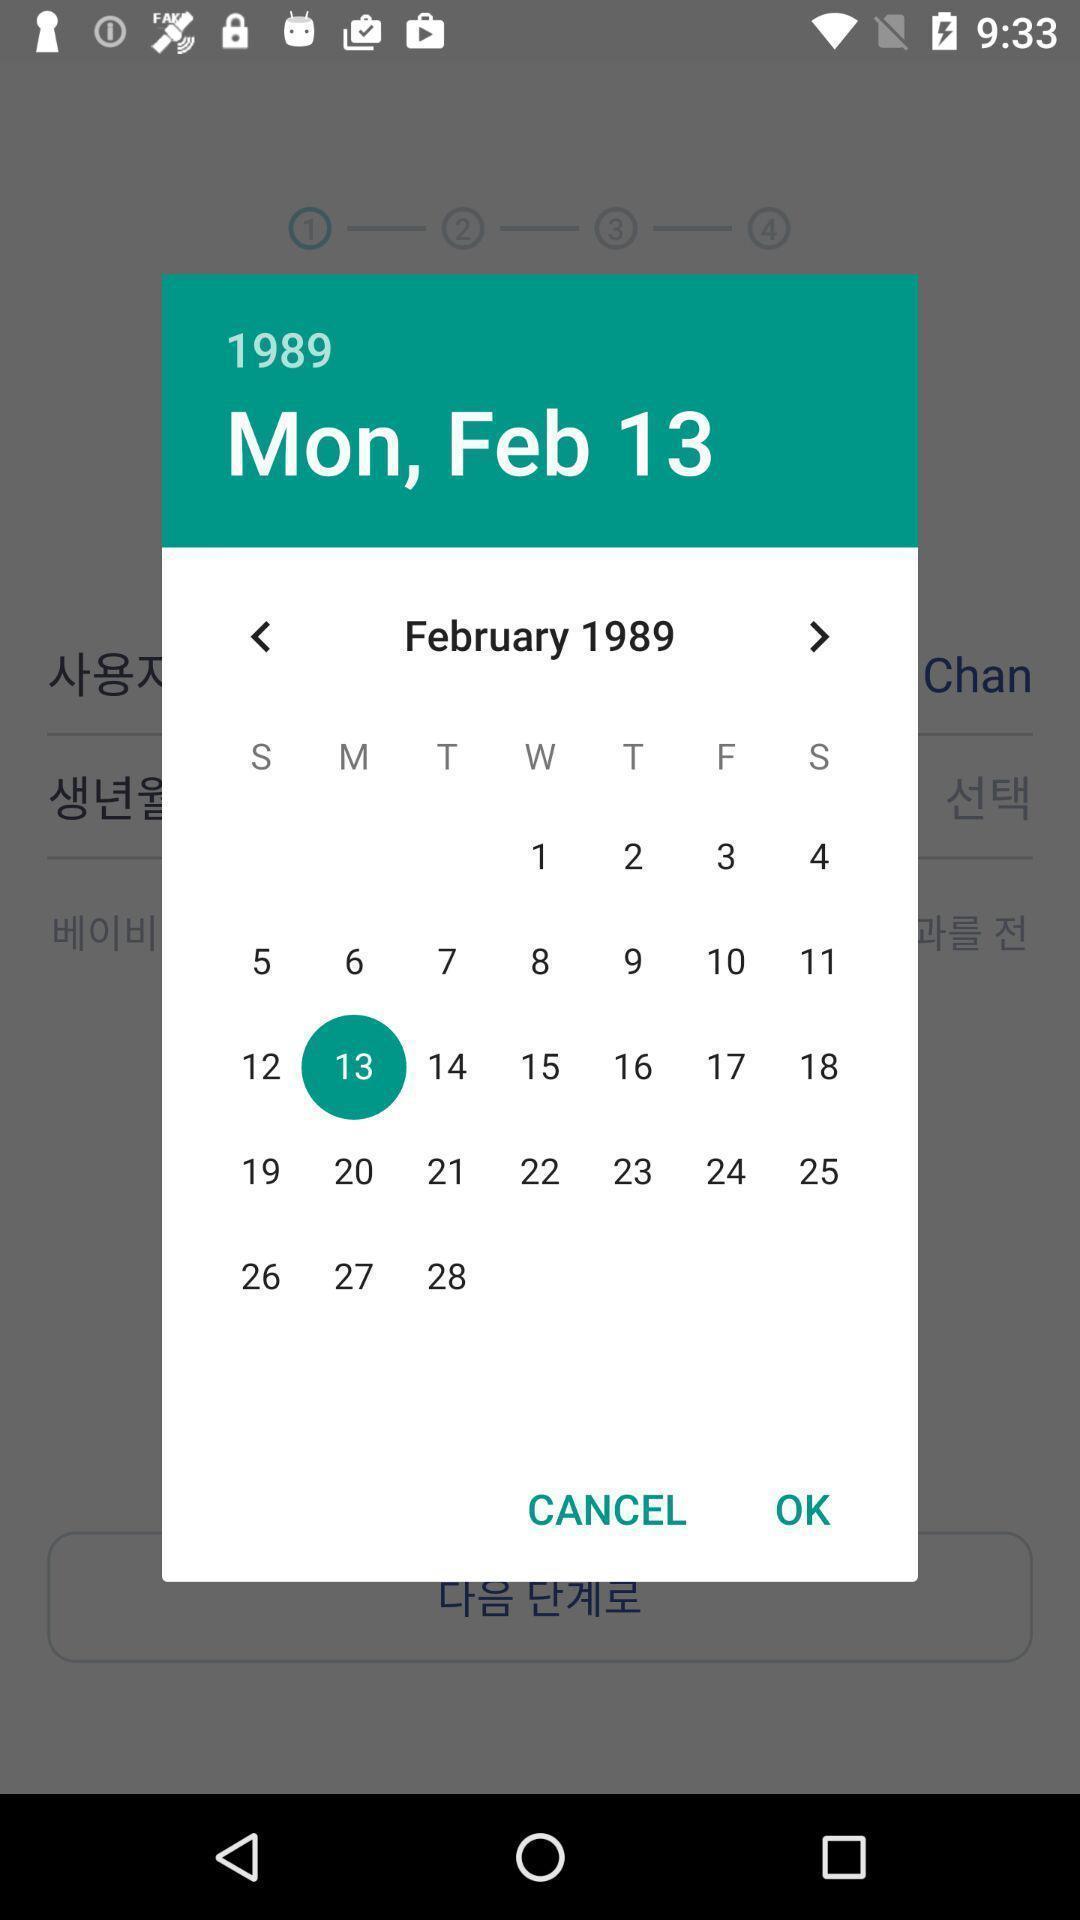Give me a narrative description of this picture. Pop-up displaying calendar to select a date. 